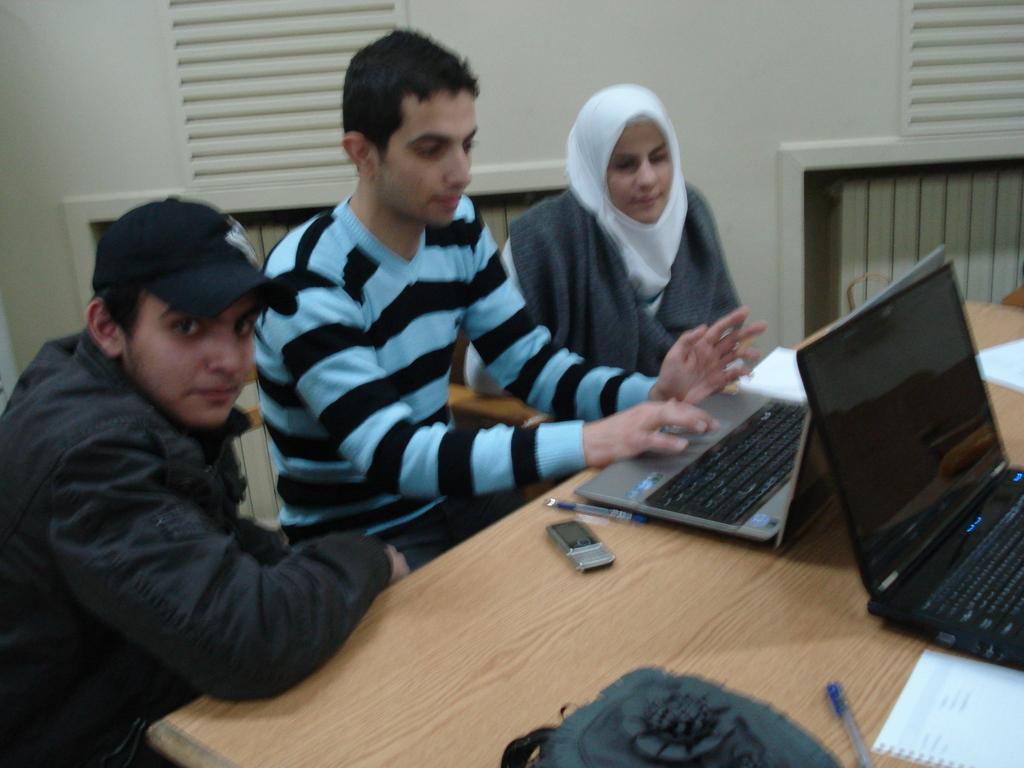Please provide a concise description of this image. In this picture there are three people sitting on the chair in front of a table. One of them is staring at the camera, the second person is operating a laptop, and the third person is staring at the laptop. 